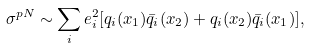<formula> <loc_0><loc_0><loc_500><loc_500>\sigma ^ { p N } \sim \sum _ { i } e _ { i } ^ { 2 } [ q _ { i } ( x _ { 1 } ) \bar { q } _ { i } ( x _ { 2 } ) + q _ { i } ( x _ { 2 } ) \bar { q } _ { i } ( x _ { 1 } ) ] ,</formula> 